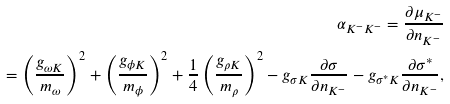Convert formula to latex. <formula><loc_0><loc_0><loc_500><loc_500>\alpha _ { K ^ { - } K ^ { - } } = \frac { \partial \mu _ { K ^ { - } } } { \partial n _ { K ^ { - } } } \\ = \left ( \frac { g _ { \omega K } } { m _ { \omega } } \right ) ^ { 2 } + \left ( \frac { g _ { \phi K } } { m _ { \phi } } \right ) ^ { 2 } + \frac { 1 } { 4 } \left ( \frac { g _ { \rho K } } { m _ { \rho } } \right ) ^ { 2 } - g _ { \sigma K } \frac { \partial \sigma } { \partial n _ { K ^ { - } } } - g _ { \sigma ^ { * } K } \frac { \partial \sigma ^ { * } } { \partial n _ { K ^ { - } } } ,</formula> 